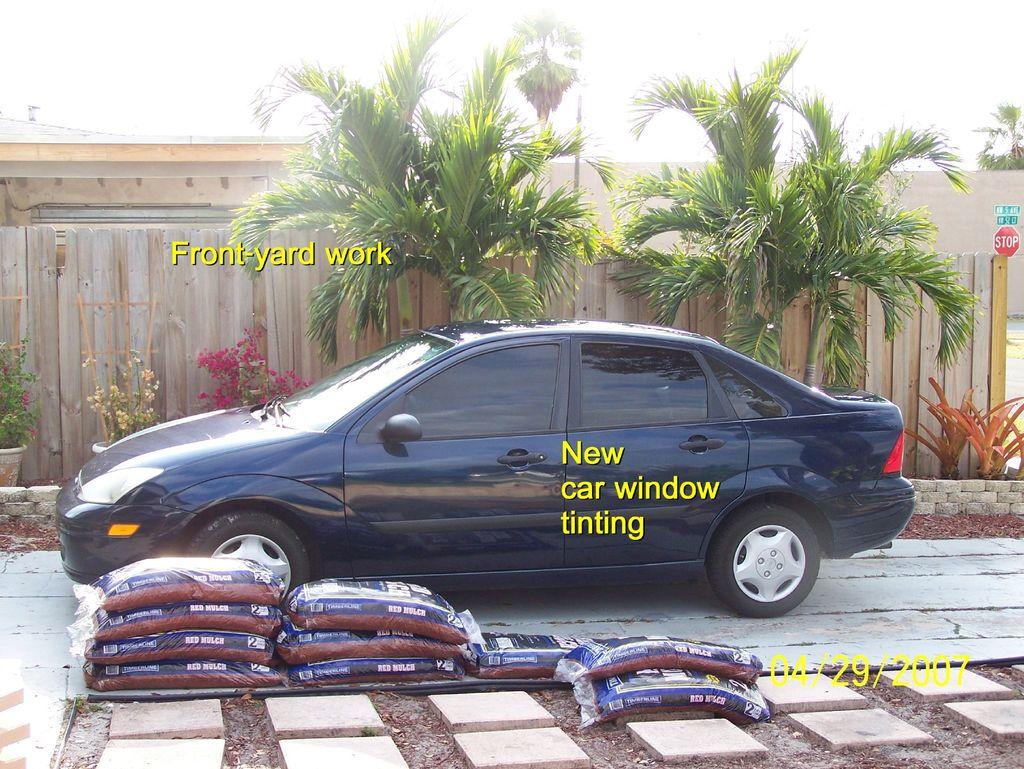Is the window rinting new?
Give a very brief answer. Yes. When was the photo taken?
Give a very brief answer. 04/29/2007. 